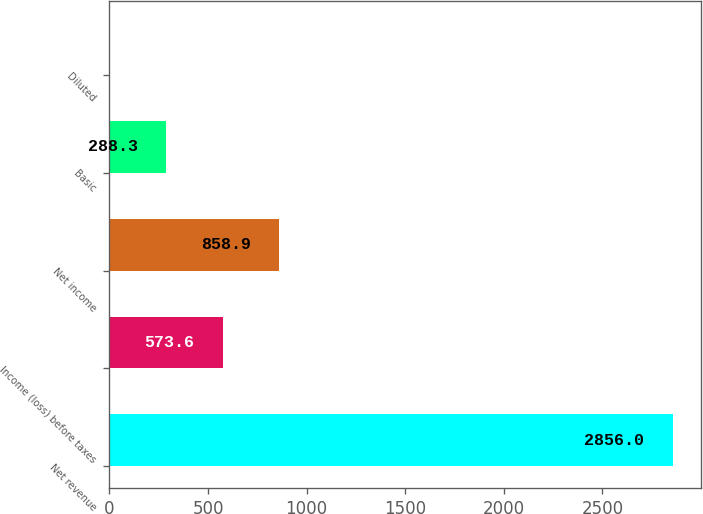Convert chart to OTSL. <chart><loc_0><loc_0><loc_500><loc_500><bar_chart><fcel>Net revenue<fcel>Income (loss) before taxes<fcel>Net income<fcel>Basic<fcel>Diluted<nl><fcel>2856<fcel>573.6<fcel>858.9<fcel>288.3<fcel>3<nl></chart> 